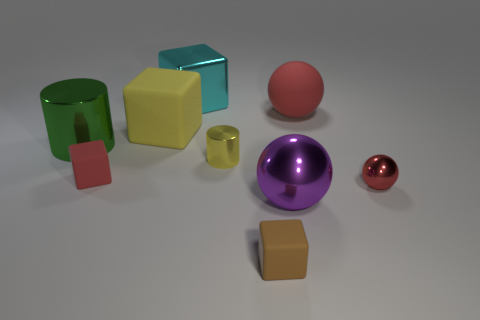Are there any big metallic things of the same color as the metallic cube?
Give a very brief answer. No. There is a sphere on the left side of the big red rubber sphere; does it have the same color as the rubber sphere?
Your answer should be compact. No. How many things are big balls in front of the big red object or large rubber blocks?
Give a very brief answer. 2. There is a brown rubber cube; are there any large rubber things in front of it?
Offer a very short reply. No. What is the material of the tiny object that is the same color as the large matte block?
Provide a succinct answer. Metal. Is the material of the tiny red object on the right side of the tiny brown object the same as the big purple sphere?
Provide a succinct answer. Yes. There is a metallic cylinder that is on the left side of the big block in front of the cyan metallic cube; is there a big green cylinder in front of it?
Provide a short and direct response. No. How many balls are either small red things or brown matte objects?
Offer a terse response. 1. What is the material of the cylinder that is left of the yellow matte cube?
Your response must be concise. Metal. What size is the thing that is the same color as the tiny cylinder?
Your answer should be compact. Large. 